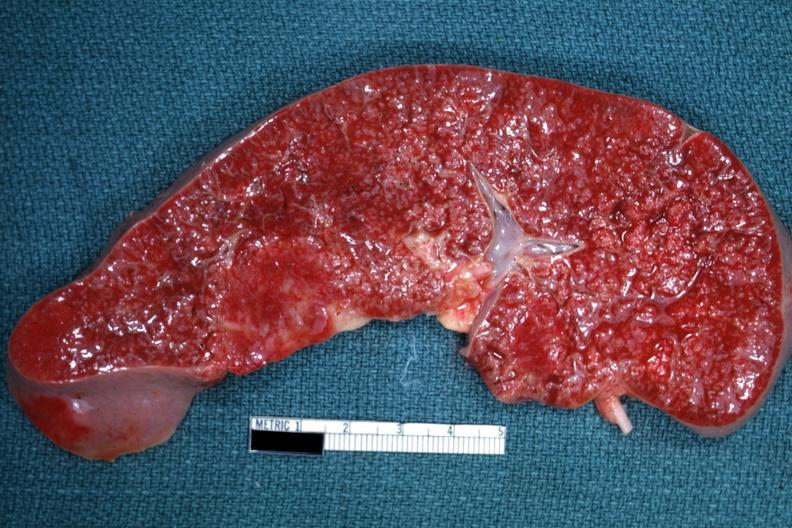what diagnosed as reticulum cell sarcoma?
Answer the question using a single word or phrase. Cut surface with multiple small infiltrates that simulate granulomata 